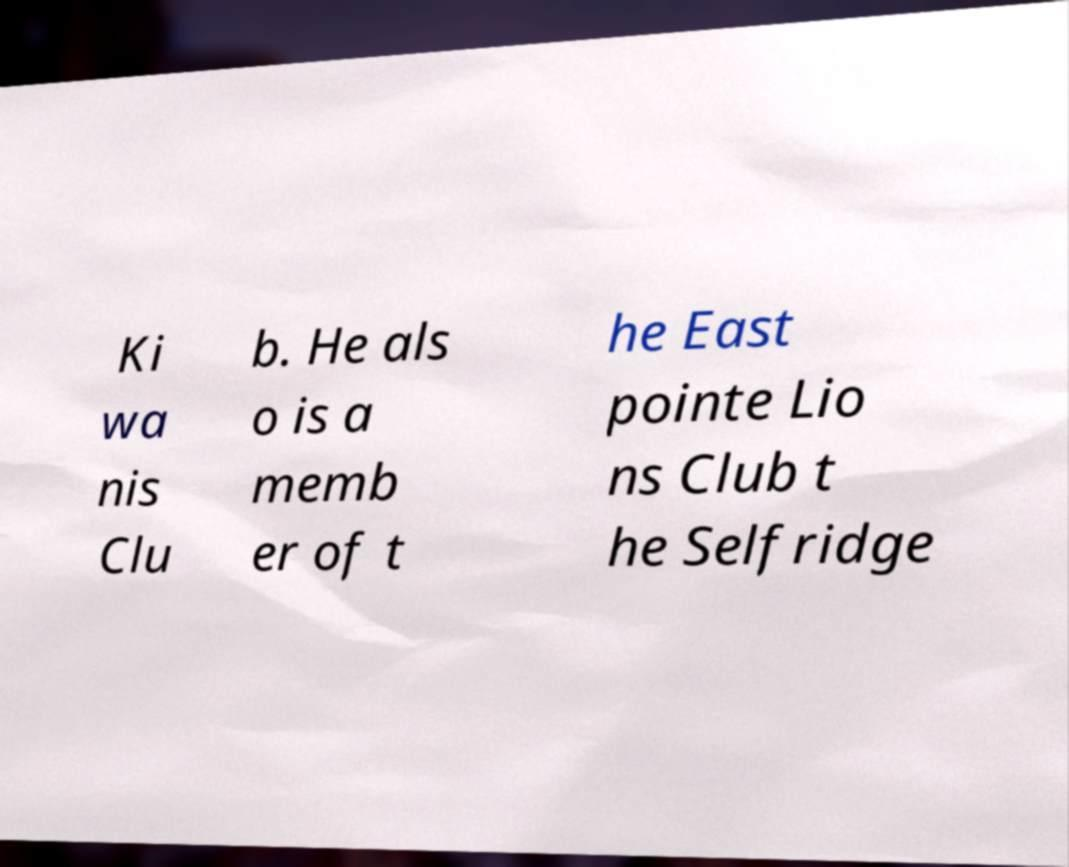Could you assist in decoding the text presented in this image and type it out clearly? Ki wa nis Clu b. He als o is a memb er of t he East pointe Lio ns Club t he Selfridge 